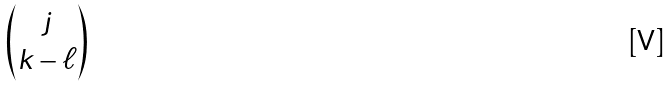Convert formula to latex. <formula><loc_0><loc_0><loc_500><loc_500>\begin{pmatrix} j \\ k - \ell \\ \end{pmatrix}</formula> 